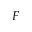Convert formula to latex. <formula><loc_0><loc_0><loc_500><loc_500>F</formula> 